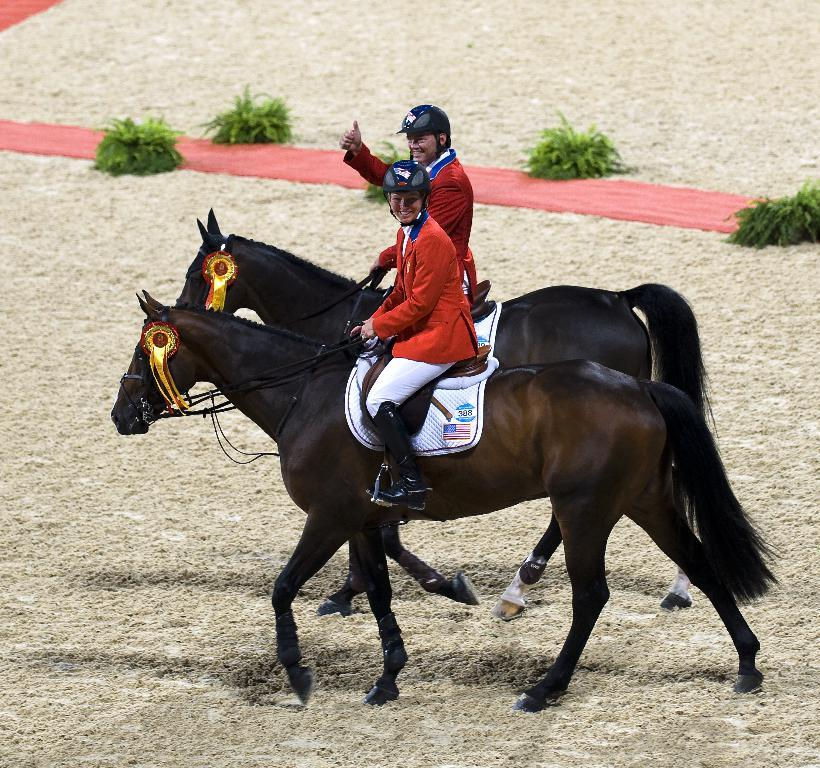How many people are on the horse in the image? There are two persons sitting on a horse in the image. What can be seen beneath the horse's feet in the image? There is a red carpet in the image. What type of vegetation is present in the image? There are plants in the image. What is the surface on which the plants are growing? The plants are on sand. Where is the sink located in the image? There is no sink present in the image. Can you tell me the total cost of the items on the receipt in the image? There is no receipt present in the image. 